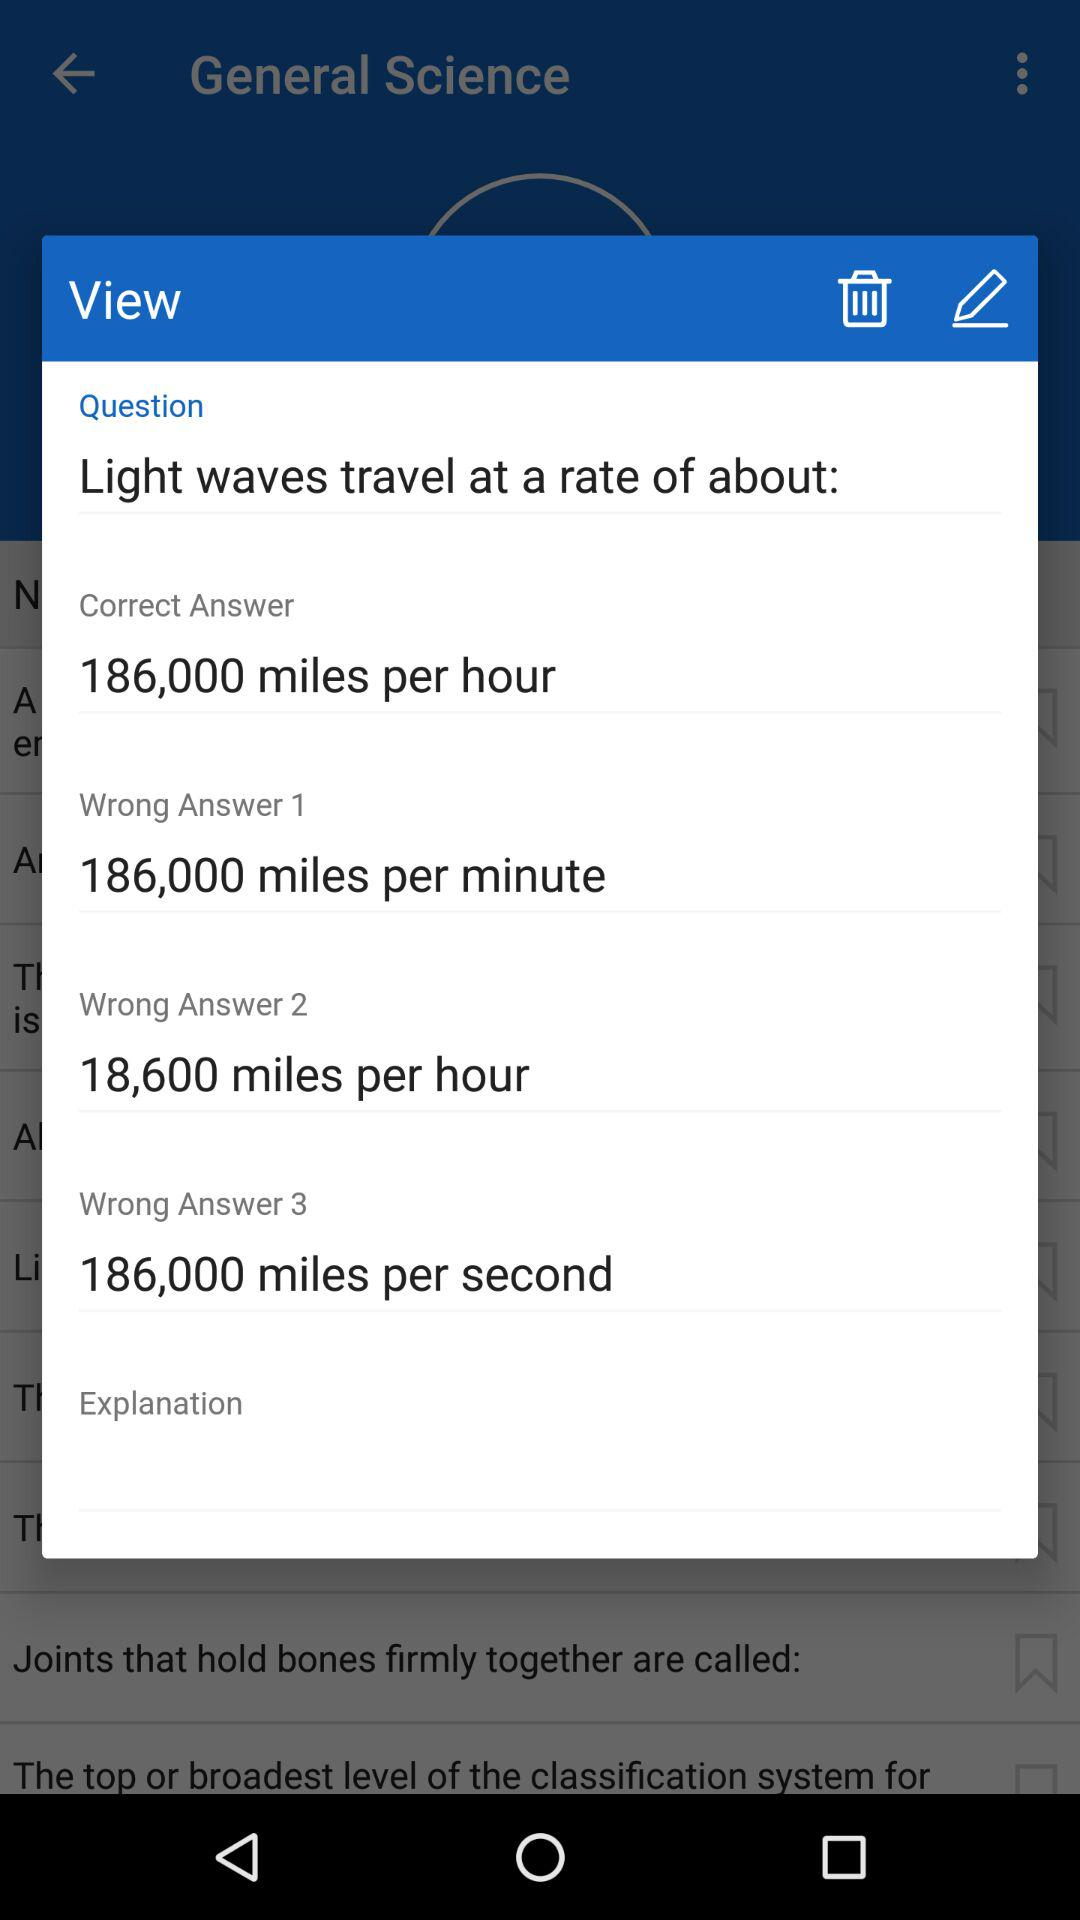What is the correct answer? The correct answer is 186,000 miles per hour. 